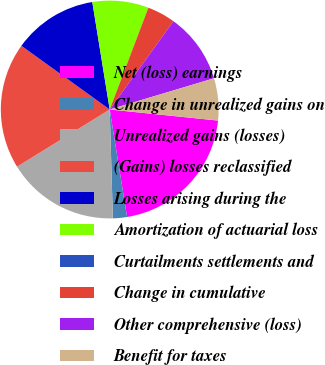Convert chart to OTSL. <chart><loc_0><loc_0><loc_500><loc_500><pie_chart><fcel>Net (loss) earnings<fcel>Change in unrealized gains on<fcel>Unrealized gains (losses)<fcel>(Gains) losses reclassified<fcel>Losses arising during the<fcel>Amortization of actuarial loss<fcel>Curtailments settlements and<fcel>Change in cumulative<fcel>Other comprehensive (loss)<fcel>Benefit for taxes<nl><fcel>20.83%<fcel>2.09%<fcel>16.66%<fcel>18.75%<fcel>12.5%<fcel>8.33%<fcel>0.01%<fcel>4.17%<fcel>10.42%<fcel>6.25%<nl></chart> 